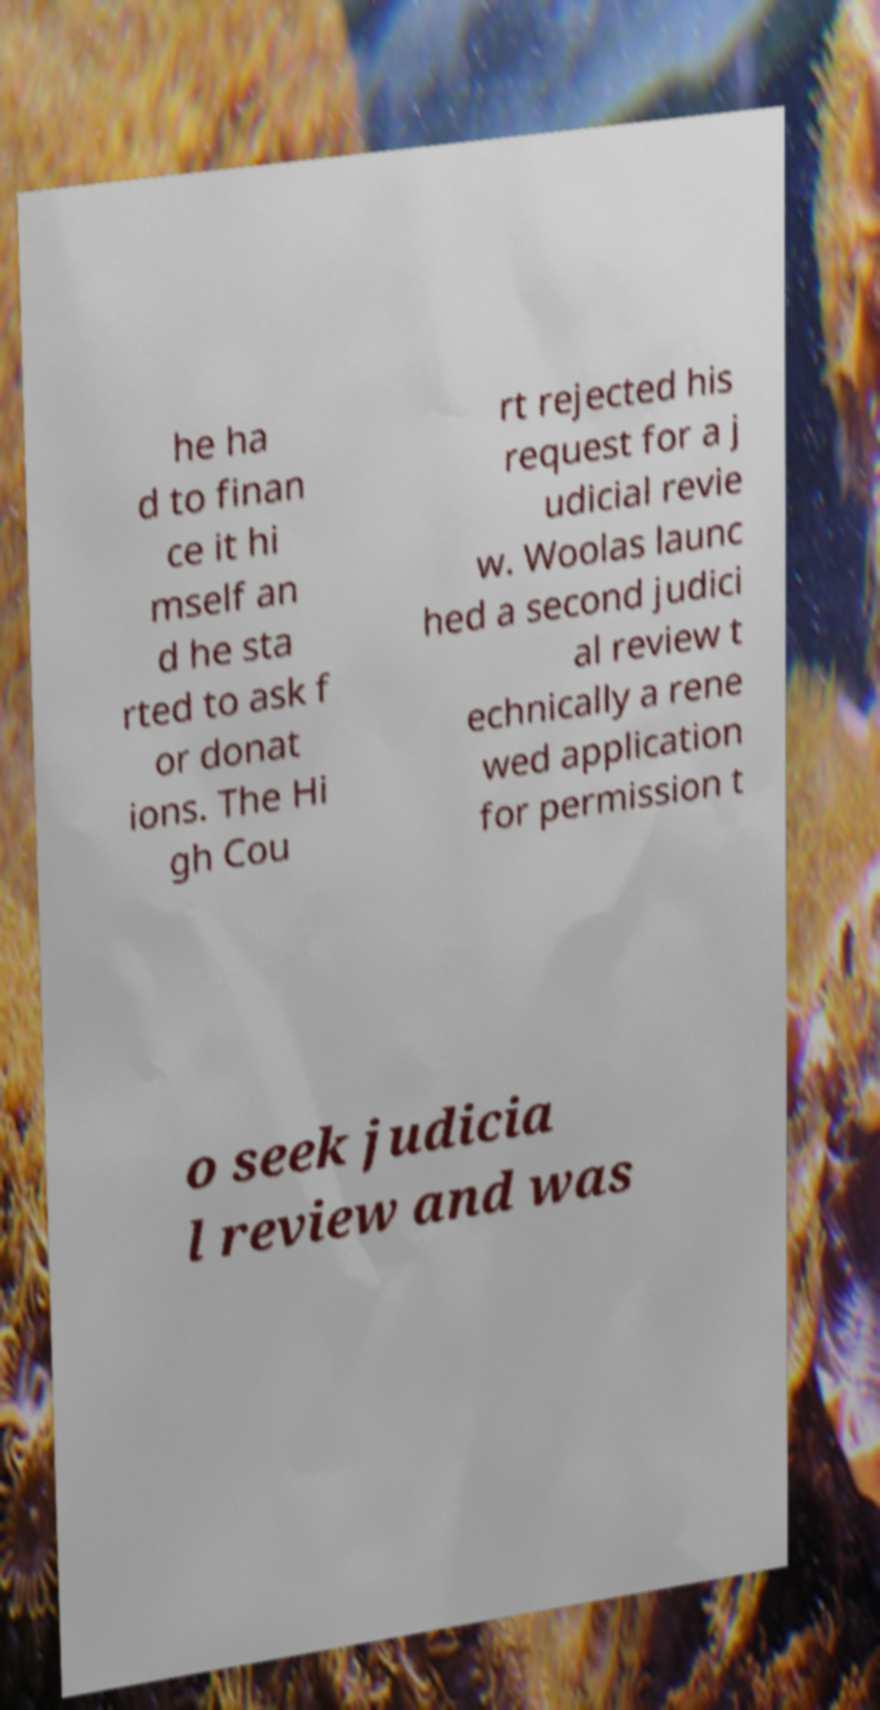Please read and relay the text visible in this image. What does it say? he ha d to finan ce it hi mself an d he sta rted to ask f or donat ions. The Hi gh Cou rt rejected his request for a j udicial revie w. Woolas launc hed a second judici al review t echnically a rene wed application for permission t o seek judicia l review and was 